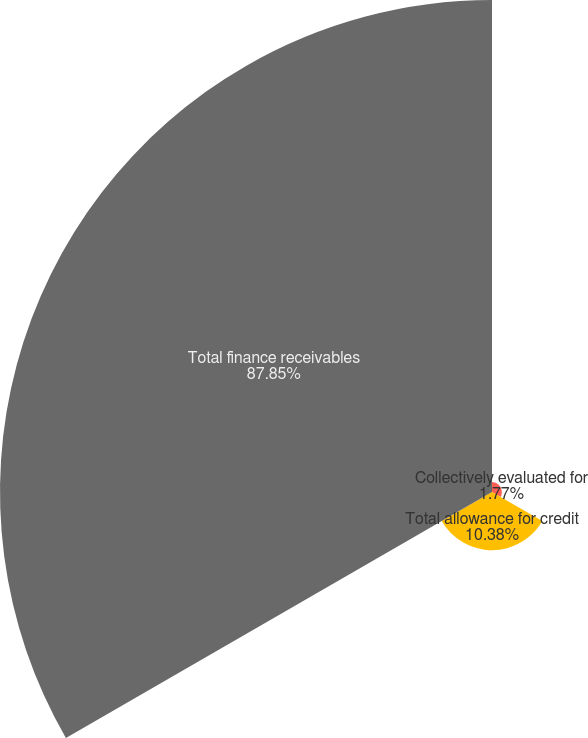Convert chart to OTSL. <chart><loc_0><loc_0><loc_500><loc_500><pie_chart><fcel>Collectively evaluated for<fcel>Total allowance for credit<fcel>Total finance receivables<nl><fcel>1.77%<fcel>10.38%<fcel>87.85%<nl></chart> 